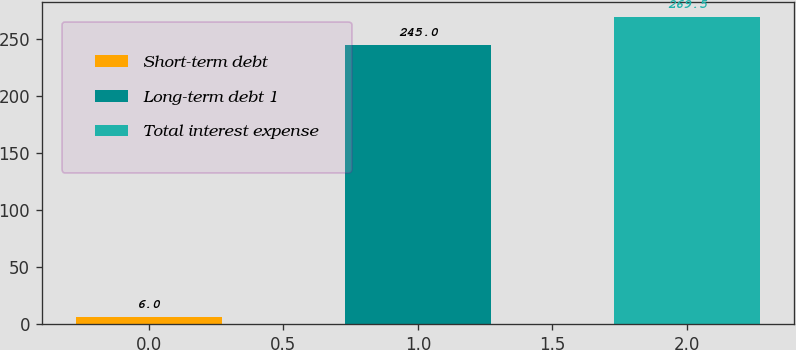<chart> <loc_0><loc_0><loc_500><loc_500><bar_chart><fcel>Short-term debt<fcel>Long-term debt 1<fcel>Total interest expense<nl><fcel>6<fcel>245<fcel>269.5<nl></chart> 